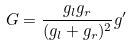<formula> <loc_0><loc_0><loc_500><loc_500>G = \frac { g _ { l } g _ { r } } { ( g _ { l } + g _ { r } ) ^ { 2 } } g ^ { \prime }</formula> 